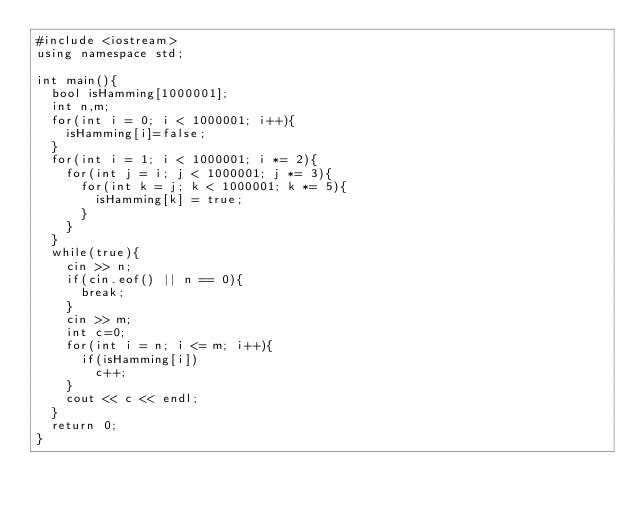<code> <loc_0><loc_0><loc_500><loc_500><_C++_>#include <iostream>
using namespace std;

int main(){
	bool isHamming[1000001];
	int n,m;
	for(int i = 0; i < 1000001; i++){
		isHamming[i]=false;
	}
	for(int i = 1; i < 1000001; i *= 2){
		for(int j = i; j < 1000001; j *= 3){
			for(int k = j; k < 1000001; k *= 5){
				isHamming[k] = true;
			}
		}
	}
	while(true){
		cin >> n;
		if(cin.eof() || n == 0){
			break;
		}
		cin >> m;
		int c=0;
		for(int i = n; i <= m; i++){
			if(isHamming[i])
				c++;
		}
		cout << c << endl;
	}
	return 0;
}
</code> 